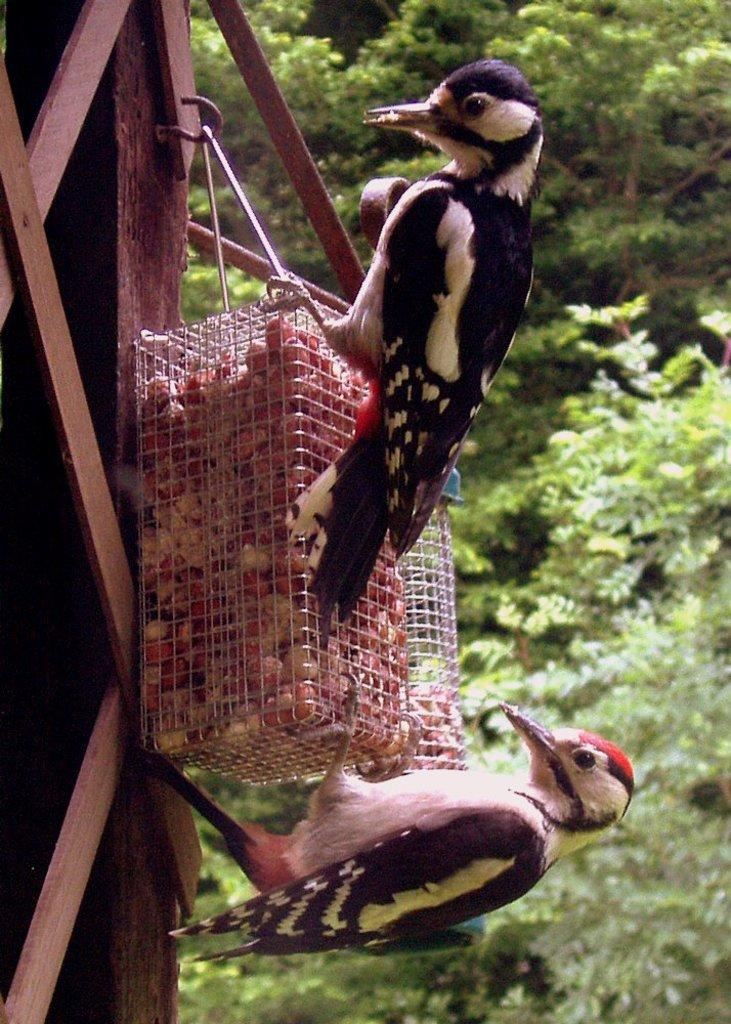What animals can be seen in the foreground of the image? There are two birds in the foreground of the image. What type of object is present in the foreground of the image? There is a wooden object in the foreground of the image. What is contained in the metal box in the foreground of the image? There are food items in a metal box in the foreground of the image. What type of vegetation can be seen in the background of the image? There are trees visible in the background of the image. Can you determine the time of day the image was taken? The image was likely taken during the day, as there is sufficient light to see the details clearly. How many laborers are working in the background of the image? There are no laborers present in the image; it features two birds, a wooden object, and food items in a metal box in the foreground, with trees visible in the background. What type of dolls can be seen playing with water in the image? There are no dolls or water present in the image; it features two birds, a wooden object, and food items in a metal box in the foreground, with trees visible in the background. 